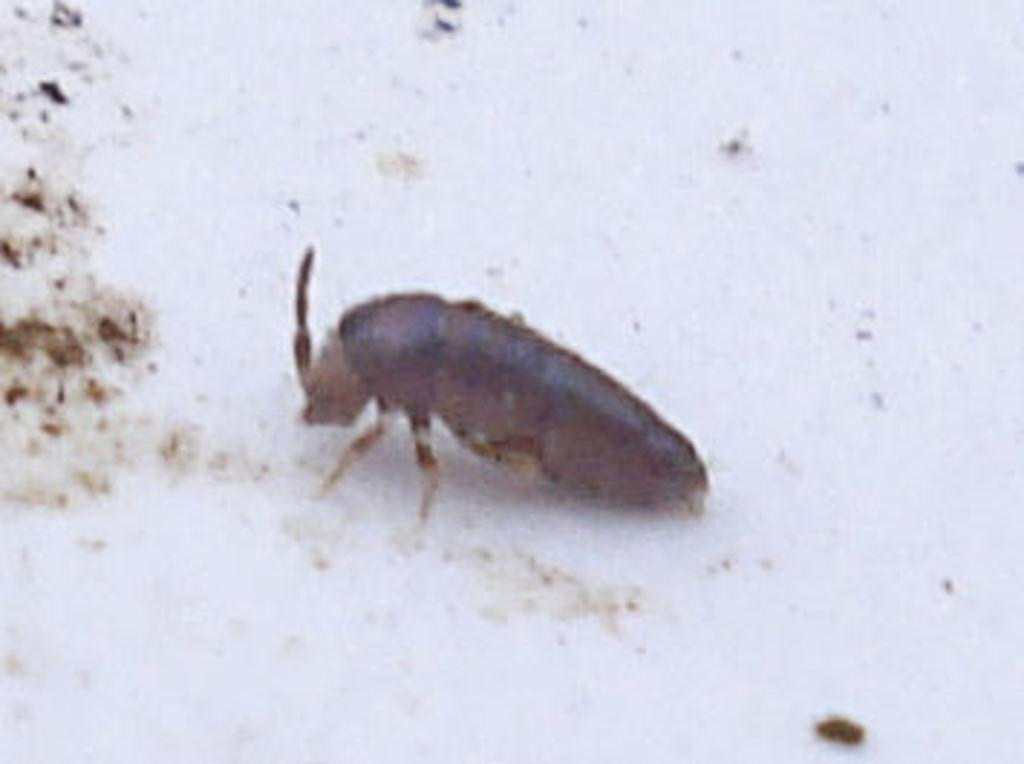What type of creature can be seen in the image? There is an insect in the image. What is the insect resting on? The insect is on a white object. What can be seen on the left side of the image? There are objects on the left side of the image. What type of home does the band live in, as seen in the image? There is no home or band present in the image; it features an insect on a white object. How many legs does the leg have in the image? There is no leg present in the image; it features an insect on a white object. 